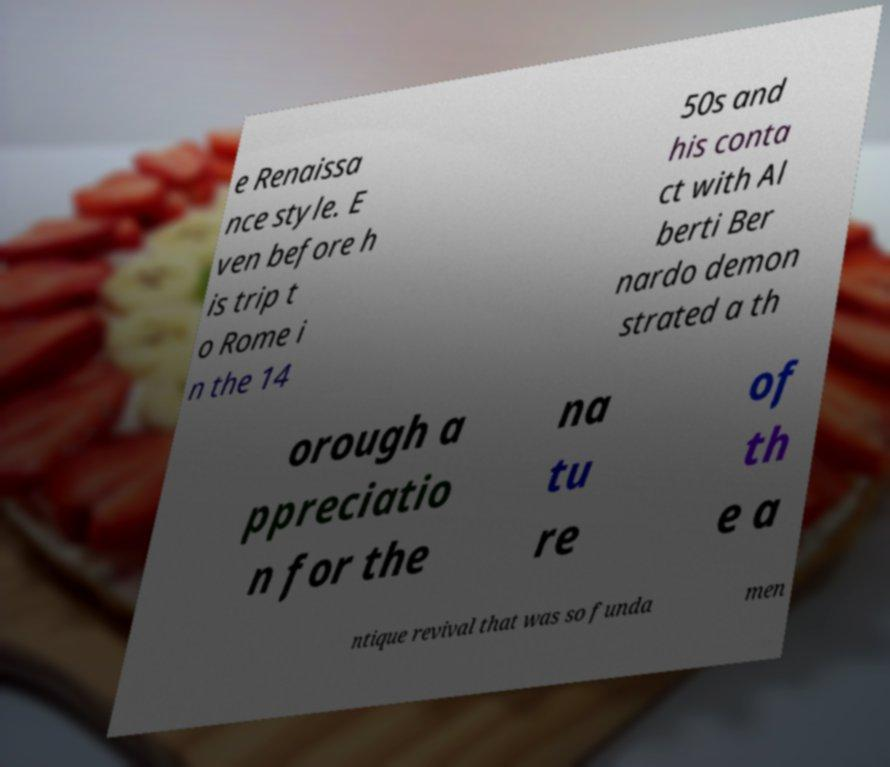Could you extract and type out the text from this image? e Renaissa nce style. E ven before h is trip t o Rome i n the 14 50s and his conta ct with Al berti Ber nardo demon strated a th orough a ppreciatio n for the na tu re of th e a ntique revival that was so funda men 